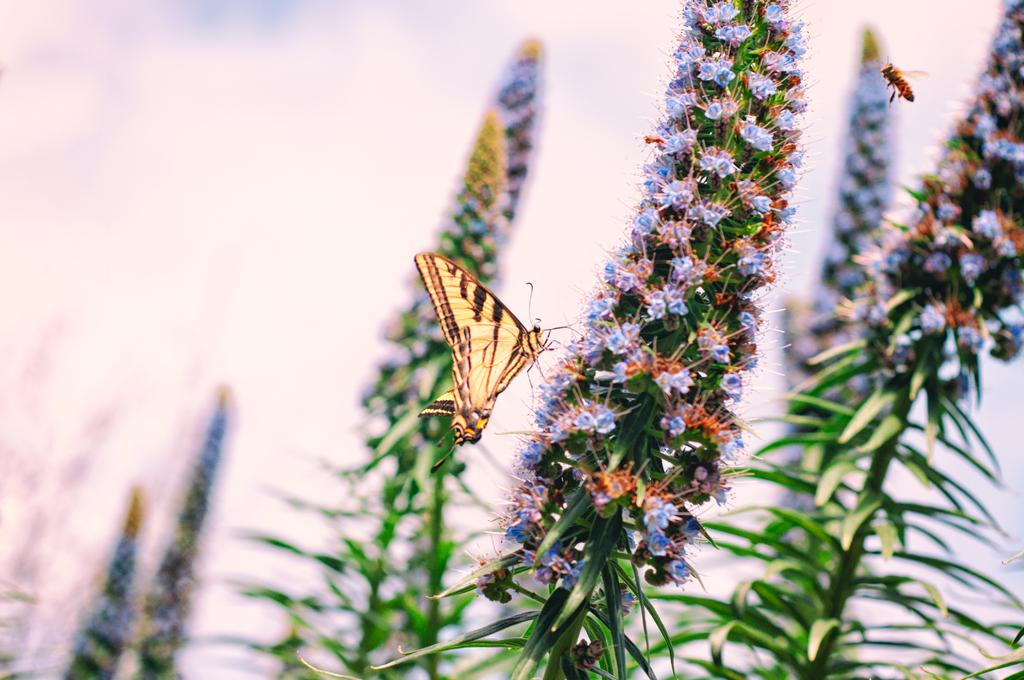What type of living organisms can be seen in the image? Plants and flowers are visible in the image. Are there any insects present in the image? Yes, there is a honey bee in the top right corner of the image, and a butterfly in the center of the image. How would you describe the background of the image? The background of the image is blurry. What type of skin condition can be seen on the butterfly in the image? There is no indication of a skin condition on the butterfly in the image, as butterflies do not have skin like humans. 